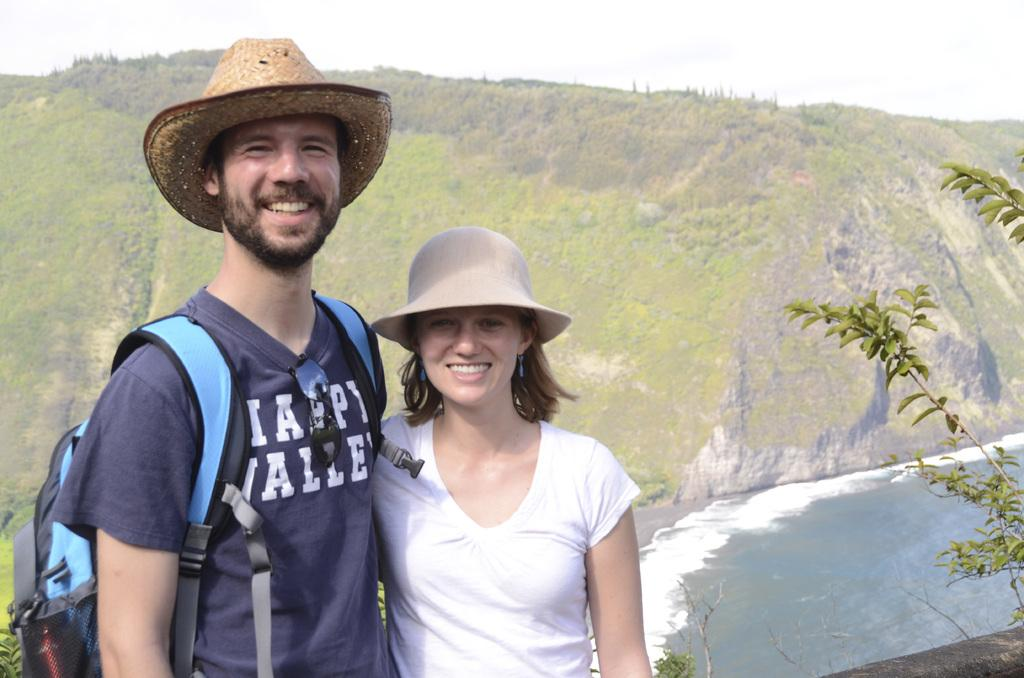<image>
Offer a succinct explanation of the picture presented. A man and a woman, the man wears a shirt that says happy valley 